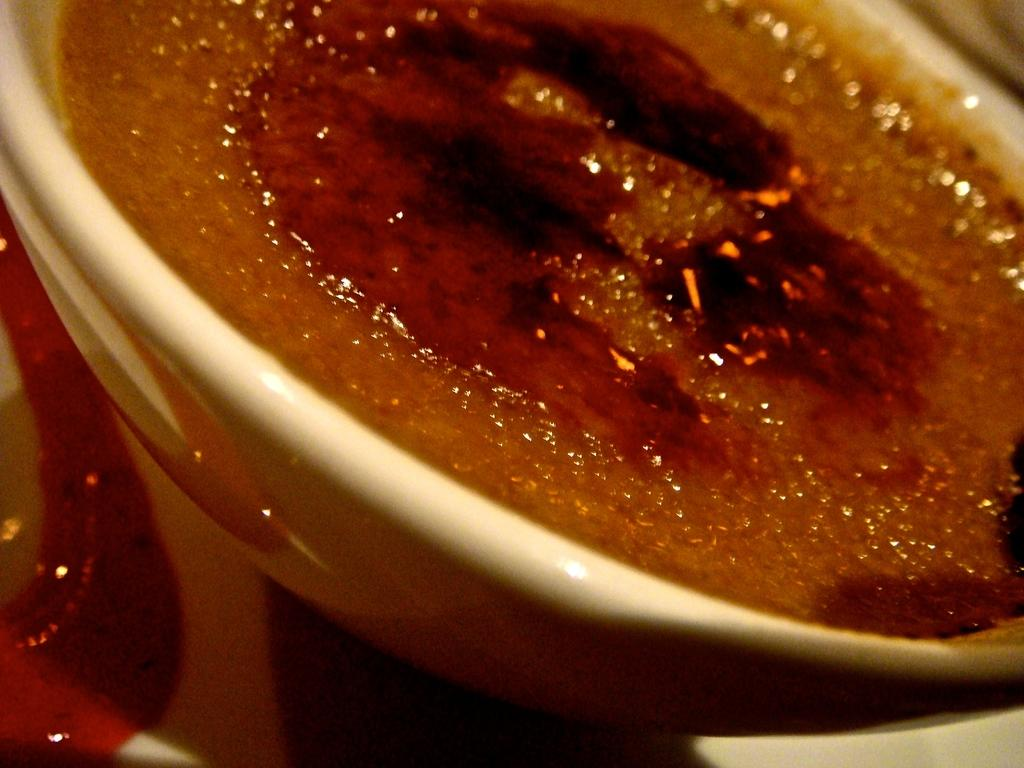What is in the bowl that is visible in the image? The bowl contains a food item. Can you describe the food item in the bowl? Unfortunately, the specific food item cannot be determined from the provided facts. What is located on the left side of the image? There is an object on the left side of the image. What type of berry is being used to express love in the image? There is no berry or expression of love present in the image. 